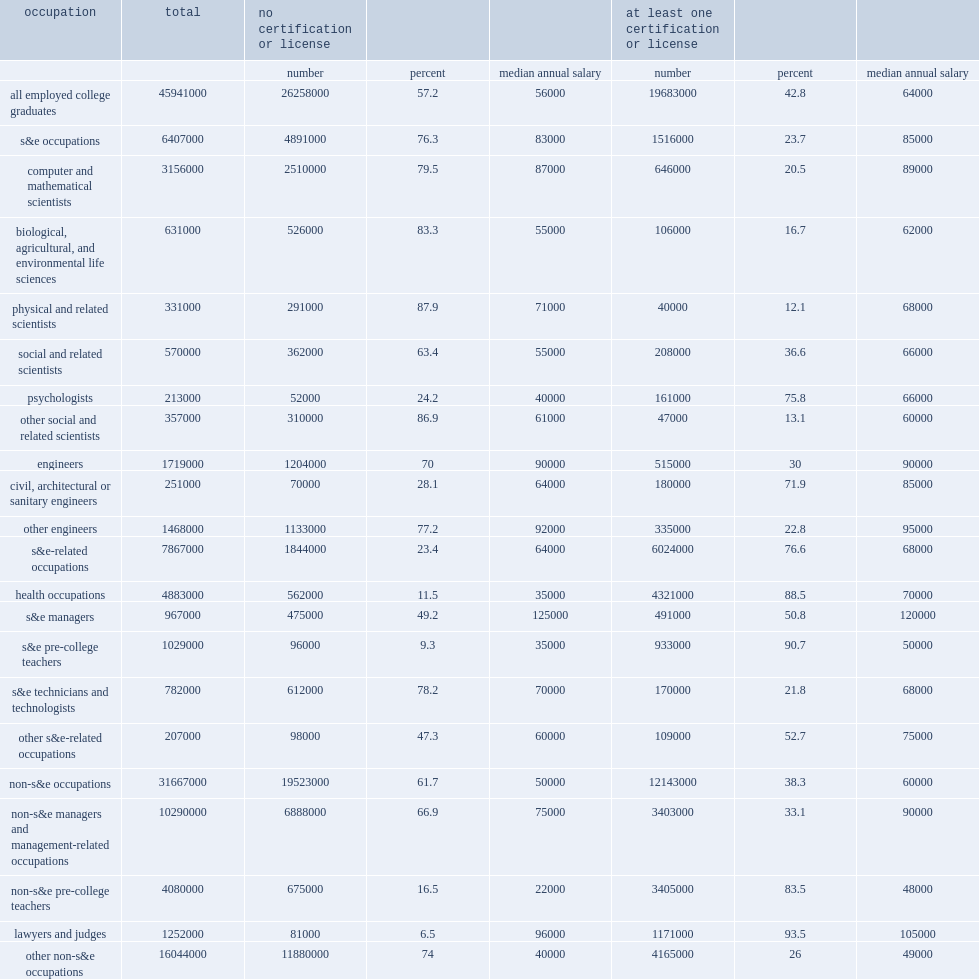Within the college-educated population, how many percent of employed individuals which were more likely to hold a currently active certification or license? 42.8. Within the college-educated population, how many percent of unemployed individuals were less likely to hold a currently active certification or license? 23.7. Within the college-educated population, how many percent of not in the labor force individuals were less likely to hold a currently active certification or license? 23.7. How many percent of the specific occupations in which college-educated workers had the highest certification or license prevalence rates were legal occupations. 93.5. How many percent of the specific occupations in which college-educated workers had the highest certification or license prevalence rates were science and engineering pre-college teachers? 90.7. How many percent of the specific occupations in which college-educated workers had the highest certification or license prevalence rates were health occupations? 88.5. How many percent of the specific occupations in which college-educated workers had the highest certification or license prevalence rates were other education-related occupations? 83.5. 